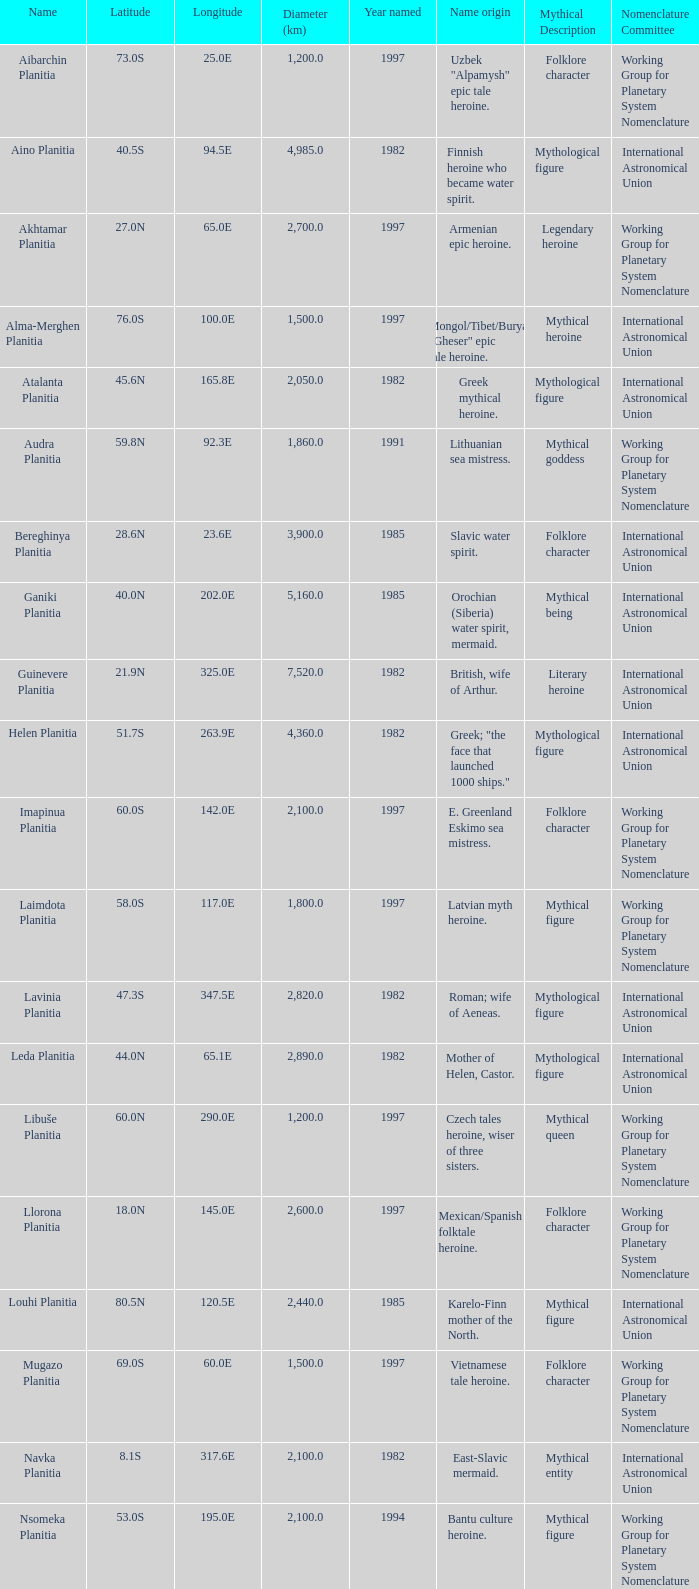What is the diameter (km) of the feature of latitude 23.0s 3000.0. 